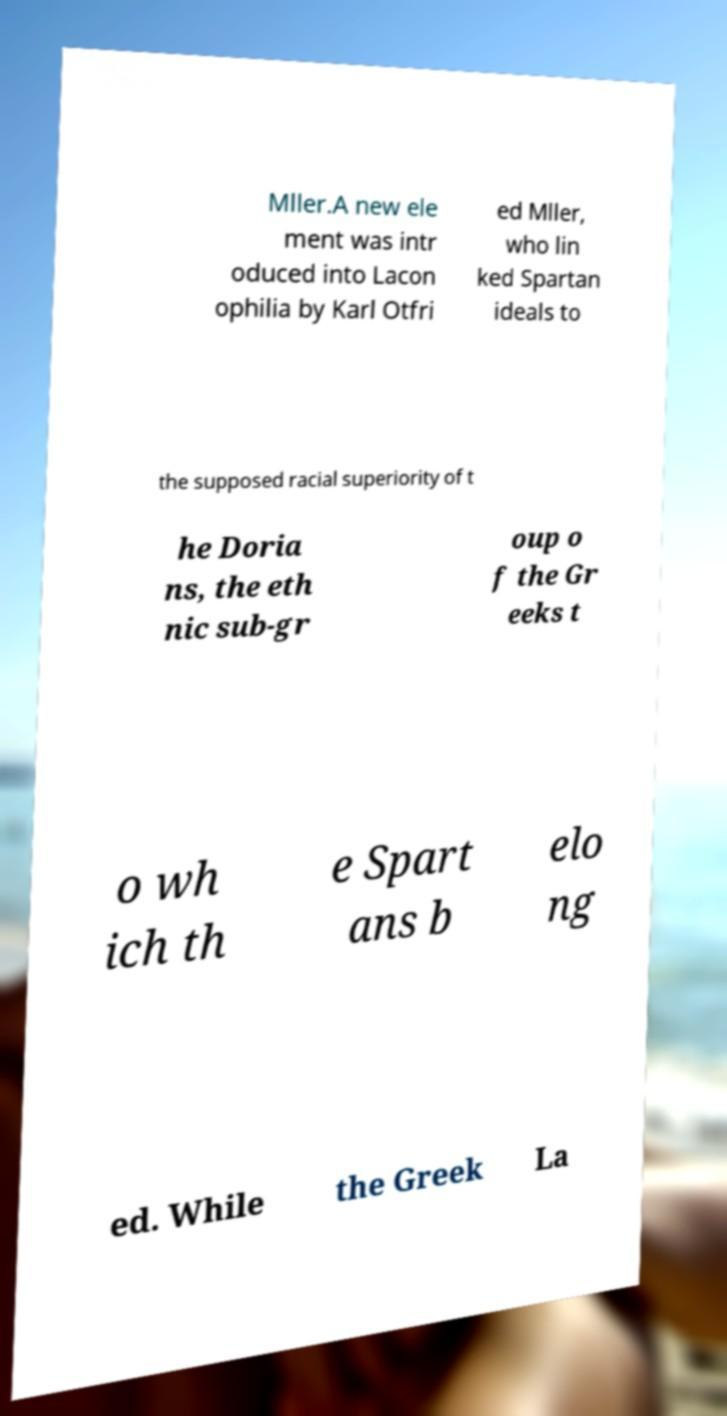Please read and relay the text visible in this image. What does it say? Mller.A new ele ment was intr oduced into Lacon ophilia by Karl Otfri ed Mller, who lin ked Spartan ideals to the supposed racial superiority of t he Doria ns, the eth nic sub-gr oup o f the Gr eeks t o wh ich th e Spart ans b elo ng ed. While the Greek La 